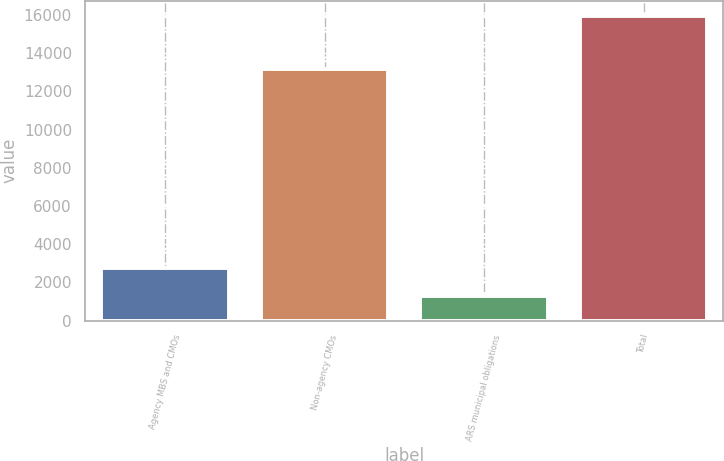Convert chart. <chart><loc_0><loc_0><loc_500><loc_500><bar_chart><fcel>Agency MBS and CMOs<fcel>Non-agency CMOs<fcel>ARS municipal obligations<fcel>Total<nl><fcel>2736.8<fcel>13152<fcel>1268<fcel>15956<nl></chart> 